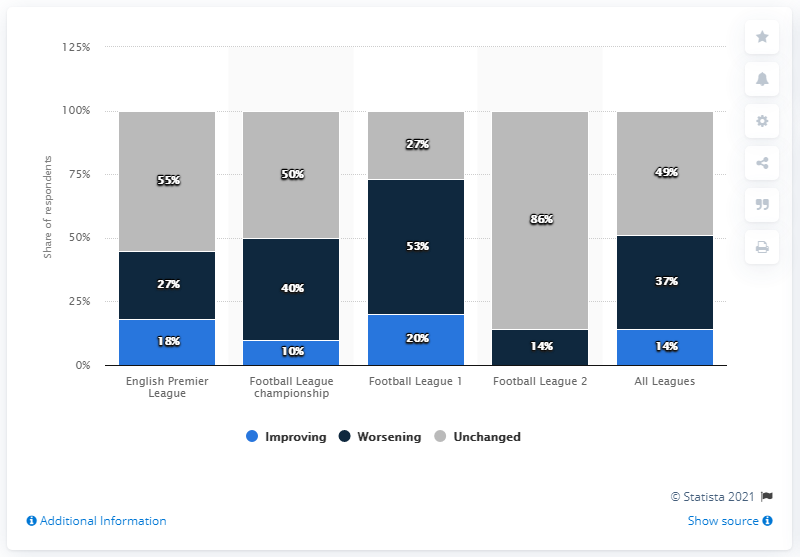Indicate a few pertinent items in this graphic. Sixty-two percent of respondents believe that the situation is improving. Color gray indicates no change or no variation. 